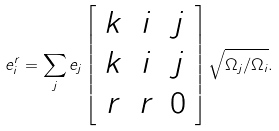<formula> <loc_0><loc_0><loc_500><loc_500>e ^ { r } _ { i } = \sum _ { j } e _ { j } \left [ \begin{array} { c c c } k & i & j \\ k & i & j \\ r & r & 0 \end{array} \right ] \sqrt { \Omega _ { j } / \Omega _ { i } } .</formula> 